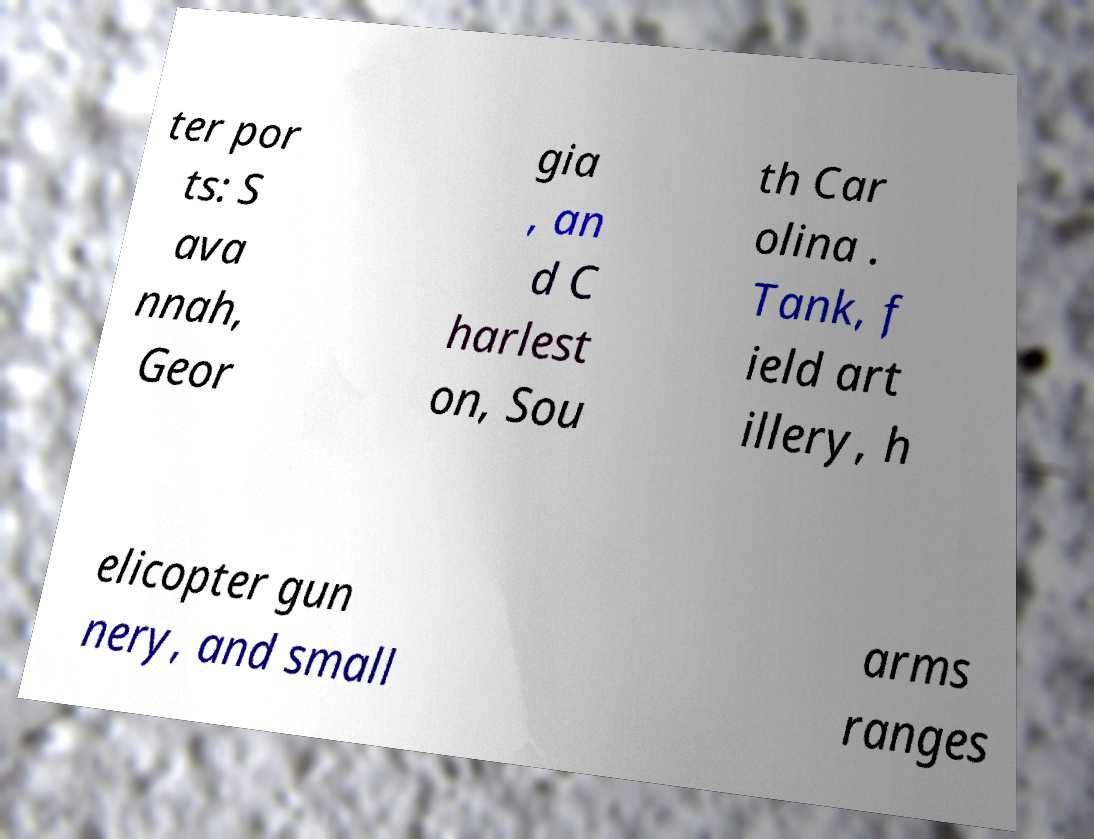There's text embedded in this image that I need extracted. Can you transcribe it verbatim? ter por ts: S ava nnah, Geor gia , an d C harlest on, Sou th Car olina . Tank, f ield art illery, h elicopter gun nery, and small arms ranges 